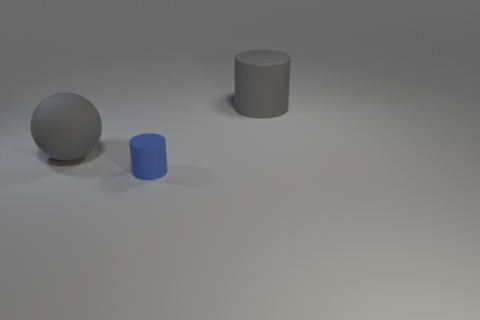Is there a large sphere to the right of the rubber thing behind the big rubber ball?
Ensure brevity in your answer.  No. Are there any blue rubber things of the same size as the gray cylinder?
Your response must be concise. No. There is a object that is in front of the big gray ball; does it have the same color as the rubber ball?
Your answer should be compact. No. The gray rubber sphere is what size?
Your answer should be compact. Large. There is a object that is right of the matte cylinder in front of the matte sphere; what is its size?
Provide a succinct answer. Large. How many large rubber objects have the same color as the sphere?
Your answer should be very brief. 1. What number of large brown metal objects are there?
Make the answer very short. 0. How many cylinders have the same material as the sphere?
Keep it short and to the point. 2. What is the size of the other thing that is the same shape as the tiny blue object?
Provide a succinct answer. Large. What is the material of the large ball?
Keep it short and to the point. Rubber. 